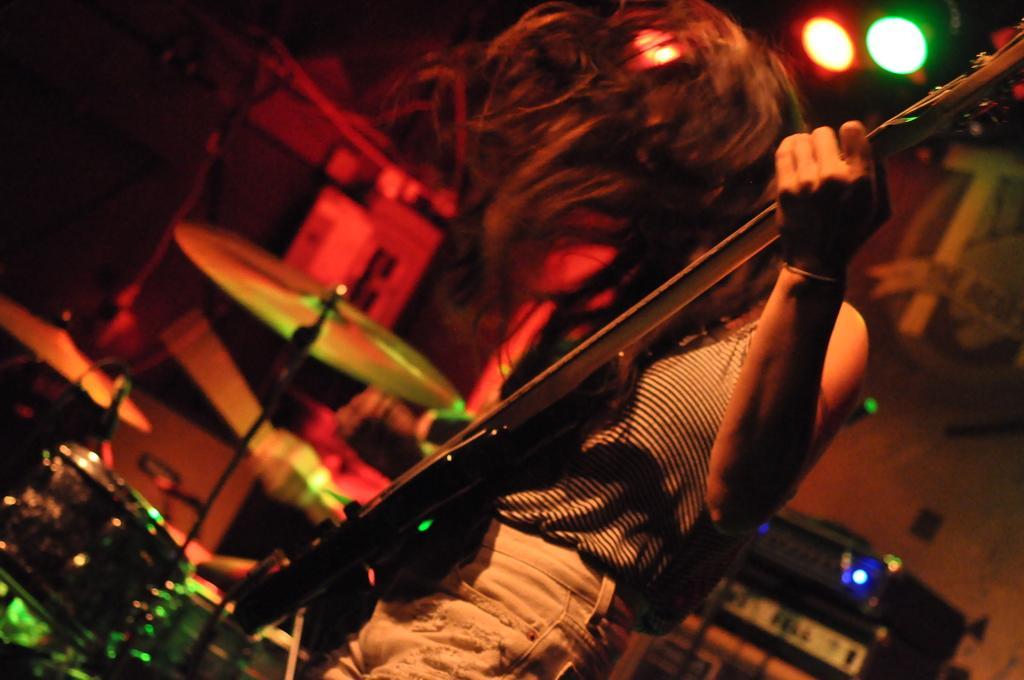Describe this image in one or two sentences. In the middle of the image a person is standing and holding a guitar. Bottom left side of the image there is a drum. Bottom right side of the image there are some musical devices. Top right side of the image there are some lights. 